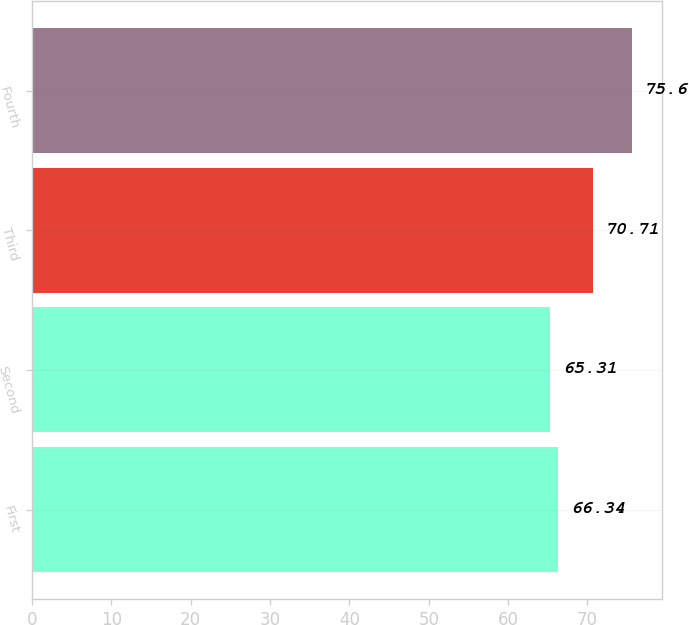Convert chart. <chart><loc_0><loc_0><loc_500><loc_500><bar_chart><fcel>First<fcel>Second<fcel>Third<fcel>Fourth<nl><fcel>66.34<fcel>65.31<fcel>70.71<fcel>75.6<nl></chart> 